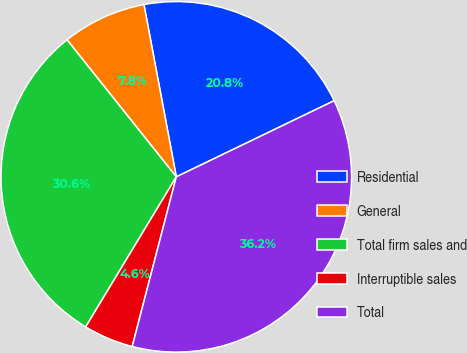Convert chart to OTSL. <chart><loc_0><loc_0><loc_500><loc_500><pie_chart><fcel>Residential<fcel>General<fcel>Total firm sales and<fcel>Interruptible sales<fcel>Total<nl><fcel>20.8%<fcel>7.76%<fcel>30.64%<fcel>4.6%<fcel>36.2%<nl></chart> 